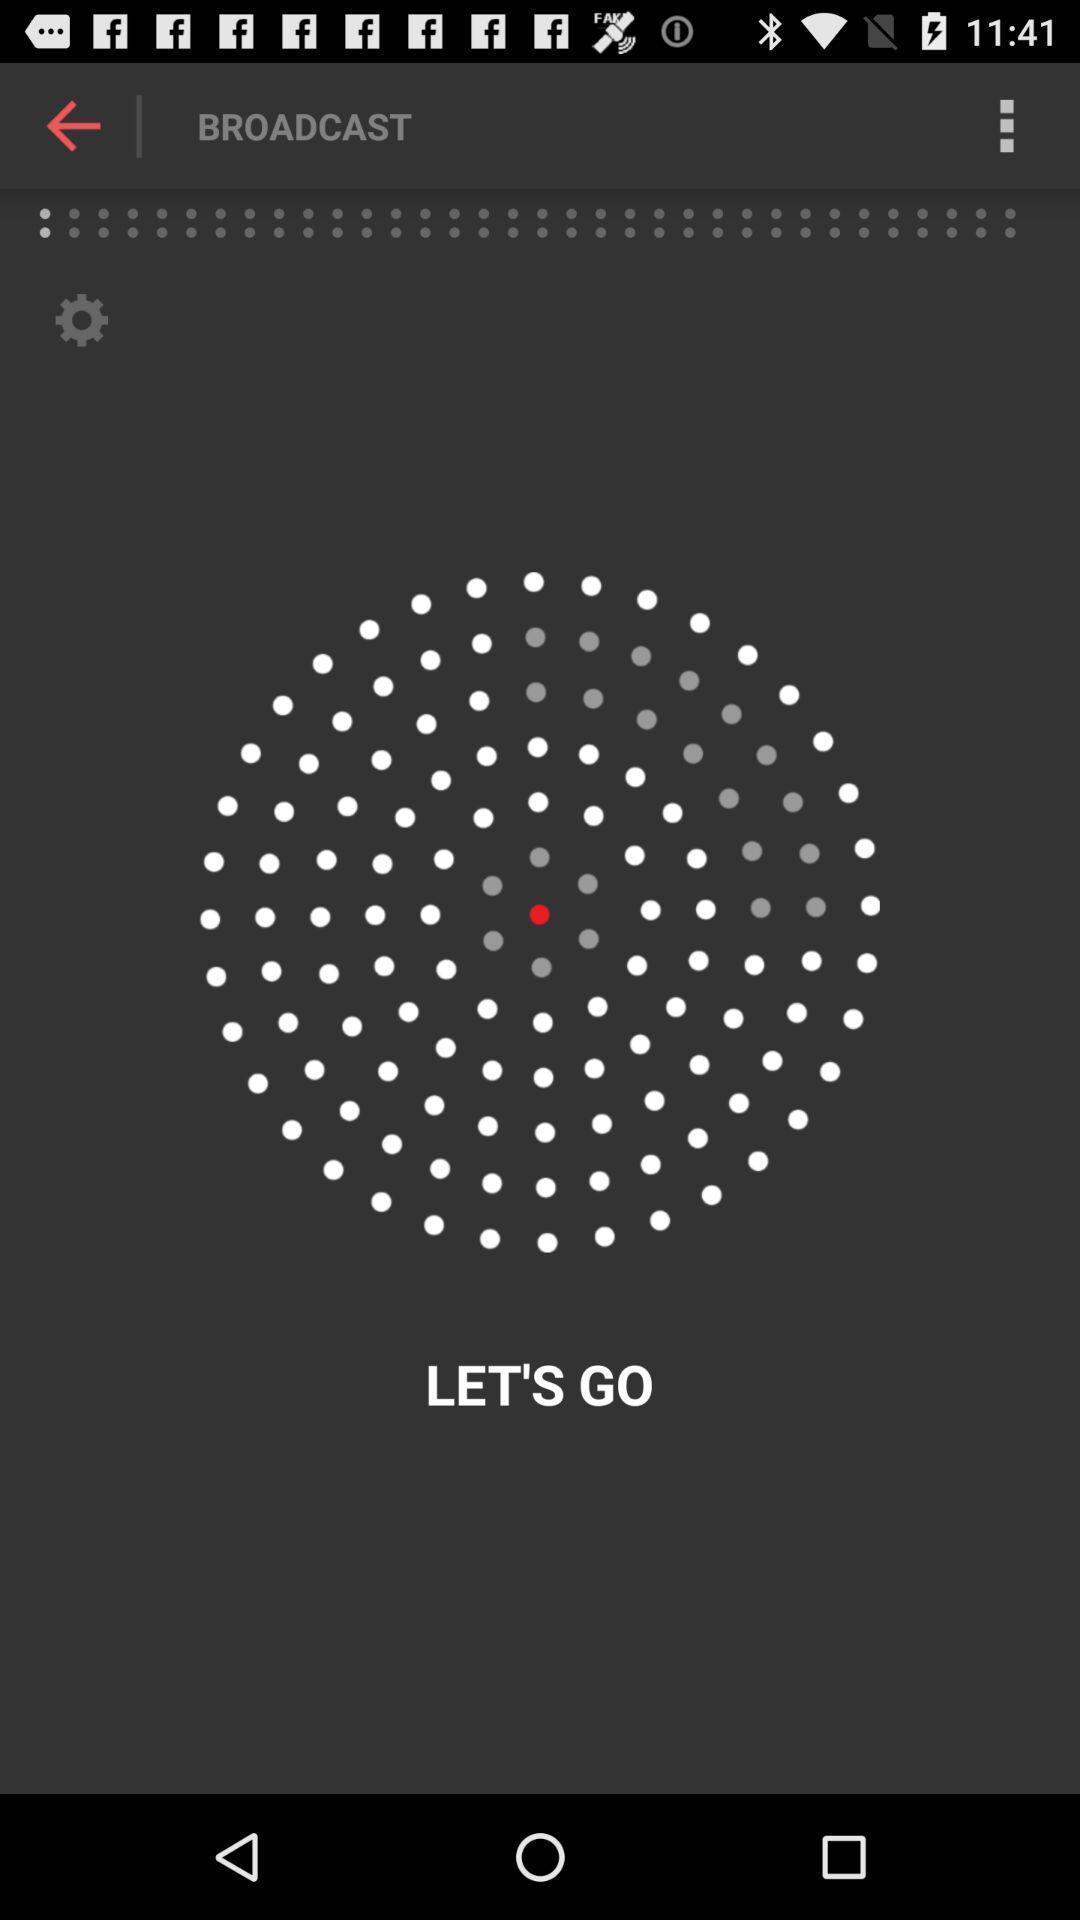Provide a detailed account of this screenshot. Start page. 